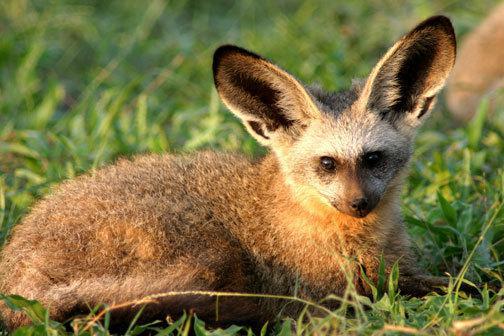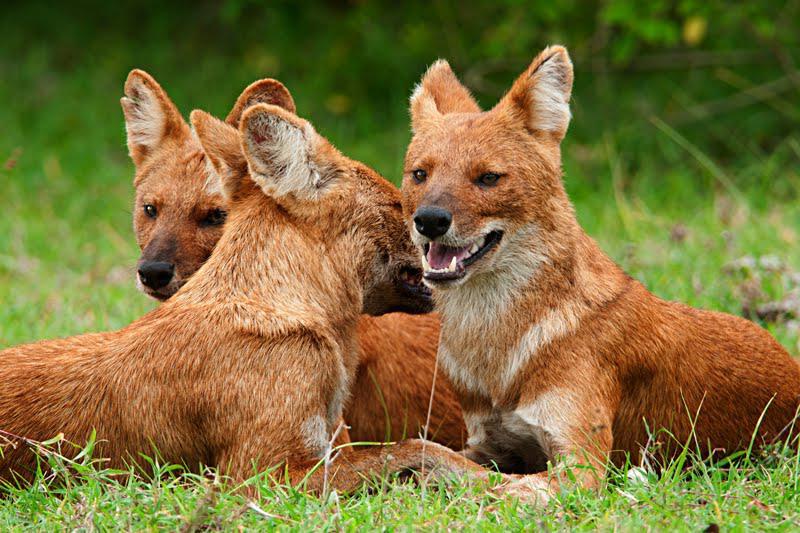The first image is the image on the left, the second image is the image on the right. Evaluate the accuracy of this statement regarding the images: "The same number of canines are shown in the left and right images.". Is it true? Answer yes or no. No. 